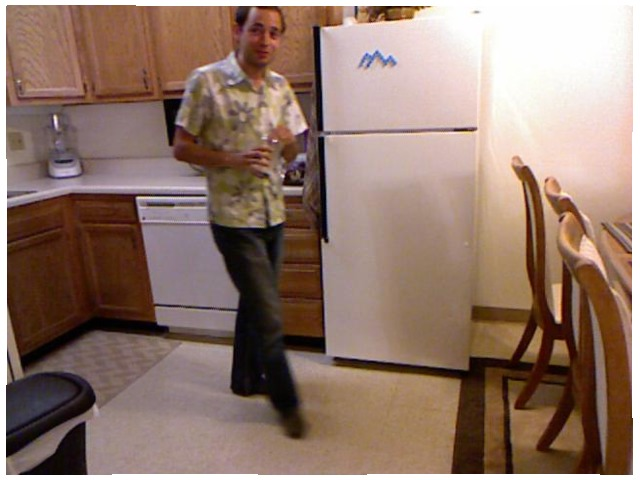<image>
Is the man on the refridgerator? No. The man is not positioned on the refridgerator. They may be near each other, but the man is not supported by or resting on top of the refridgerator. Is there a drawer behind the man? Yes. From this viewpoint, the drawer is positioned behind the man, with the man partially or fully occluding the drawer. Is the dish washer behind the man? Yes. From this viewpoint, the dish washer is positioned behind the man, with the man partially or fully occluding the dish washer. Is the refrigerator to the left of the dishwasher? No. The refrigerator is not to the left of the dishwasher. From this viewpoint, they have a different horizontal relationship. 